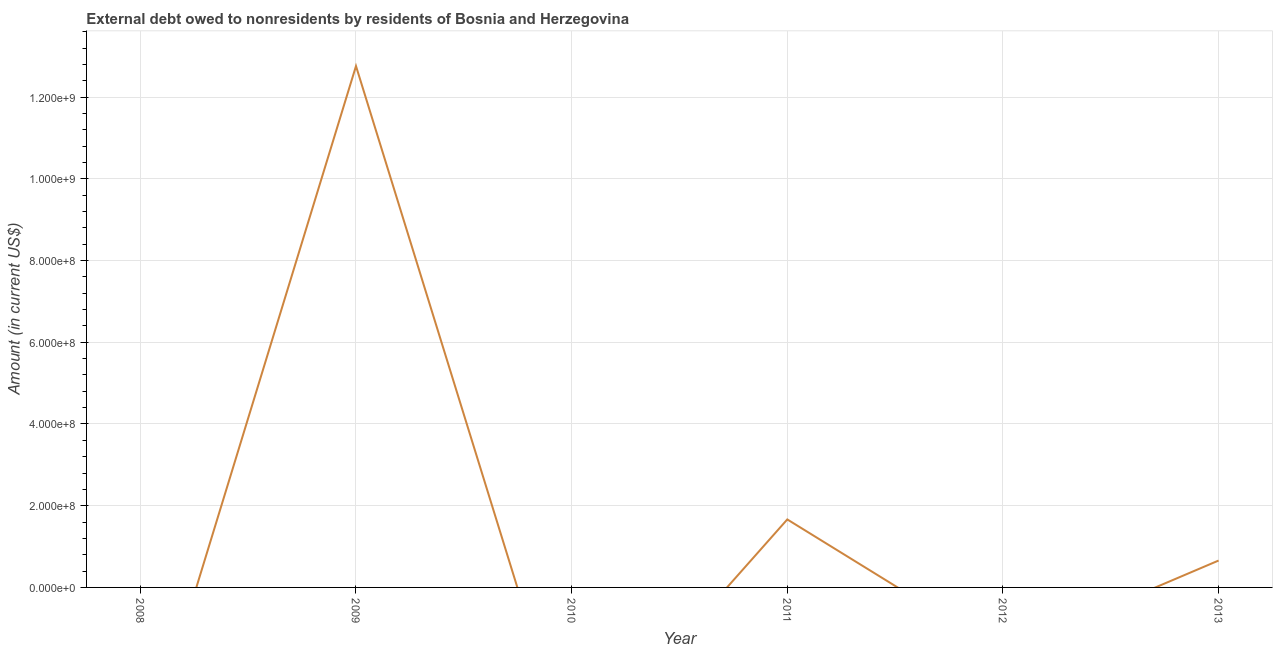What is the debt in 2010?
Your response must be concise. 0. Across all years, what is the maximum debt?
Make the answer very short. 1.28e+09. Across all years, what is the minimum debt?
Offer a very short reply. 0. In which year was the debt maximum?
Your response must be concise. 2009. What is the sum of the debt?
Make the answer very short. 1.51e+09. What is the difference between the debt in 2011 and 2013?
Offer a very short reply. 1.01e+08. What is the average debt per year?
Offer a very short reply. 2.51e+08. What is the median debt?
Ensure brevity in your answer.  3.29e+07. What is the ratio of the debt in 2009 to that in 2011?
Offer a very short reply. 7.67. Is the difference between the debt in 2011 and 2013 greater than the difference between any two years?
Offer a very short reply. No. What is the difference between the highest and the second highest debt?
Ensure brevity in your answer.  1.11e+09. What is the difference between the highest and the lowest debt?
Offer a terse response. 1.28e+09. Does the debt monotonically increase over the years?
Your answer should be compact. No. Are the values on the major ticks of Y-axis written in scientific E-notation?
Ensure brevity in your answer.  Yes. Does the graph contain any zero values?
Keep it short and to the point. Yes. Does the graph contain grids?
Give a very brief answer. Yes. What is the title of the graph?
Offer a very short reply. External debt owed to nonresidents by residents of Bosnia and Herzegovina. What is the label or title of the X-axis?
Your answer should be compact. Year. What is the Amount (in current US$) in 2009?
Ensure brevity in your answer.  1.28e+09. What is the Amount (in current US$) of 2010?
Offer a very short reply. 0. What is the Amount (in current US$) in 2011?
Give a very brief answer. 1.66e+08. What is the Amount (in current US$) of 2012?
Offer a terse response. 0. What is the Amount (in current US$) in 2013?
Keep it short and to the point. 6.58e+07. What is the difference between the Amount (in current US$) in 2009 and 2011?
Ensure brevity in your answer.  1.11e+09. What is the difference between the Amount (in current US$) in 2009 and 2013?
Provide a succinct answer. 1.21e+09. What is the difference between the Amount (in current US$) in 2011 and 2013?
Offer a terse response. 1.01e+08. What is the ratio of the Amount (in current US$) in 2009 to that in 2011?
Give a very brief answer. 7.67. What is the ratio of the Amount (in current US$) in 2009 to that in 2013?
Provide a succinct answer. 19.39. What is the ratio of the Amount (in current US$) in 2011 to that in 2013?
Your response must be concise. 2.53. 